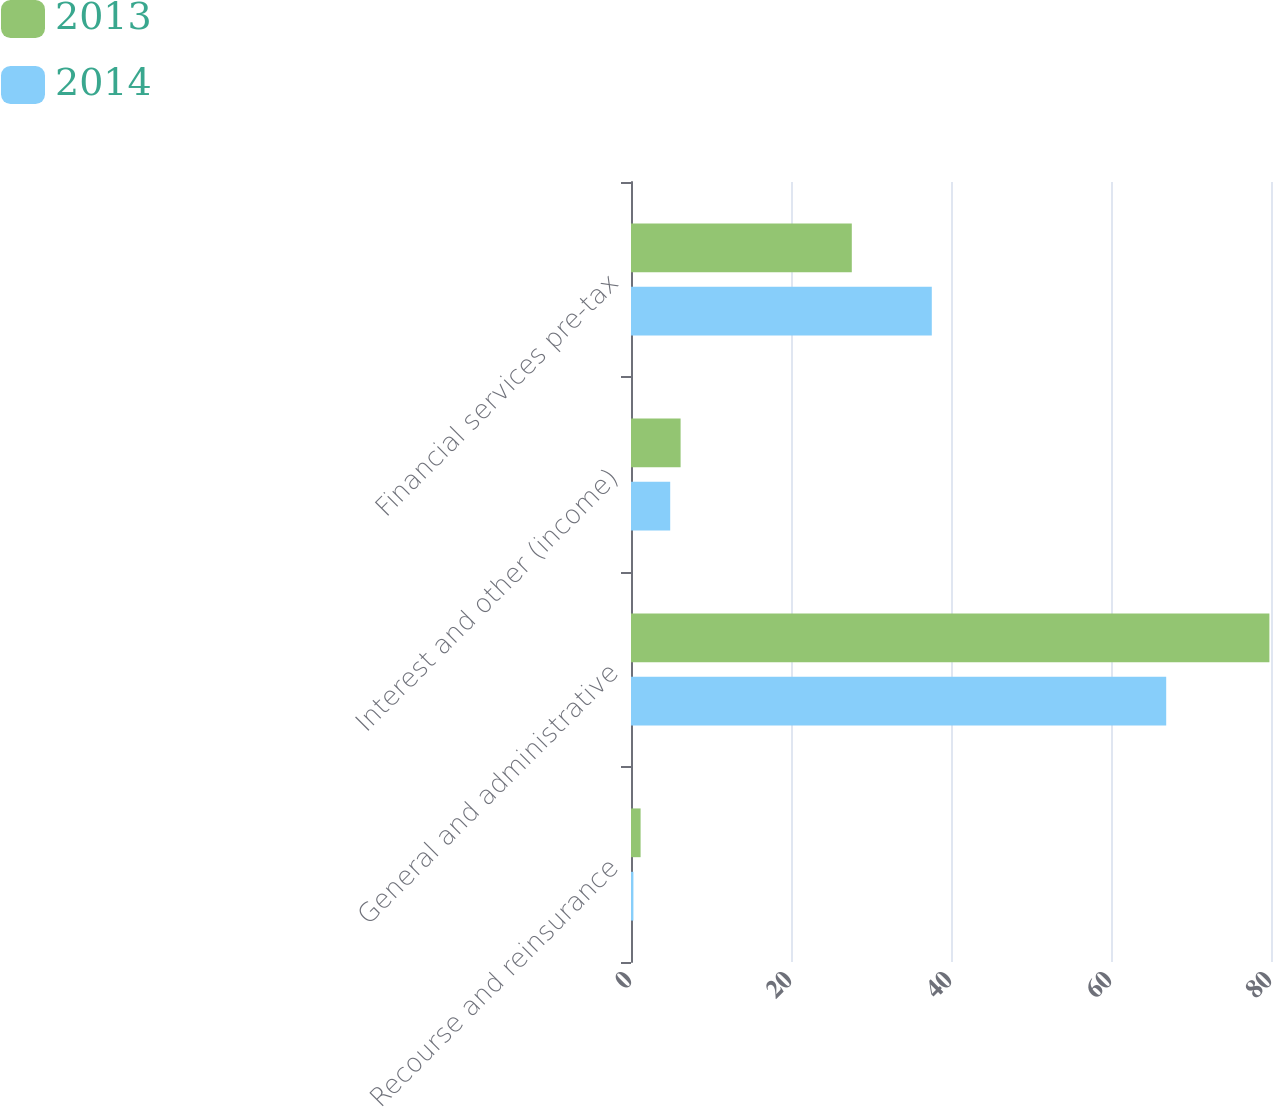<chart> <loc_0><loc_0><loc_500><loc_500><stacked_bar_chart><ecel><fcel>Recourse and reinsurance<fcel>General and administrative<fcel>Interest and other (income)<fcel>Financial services pre-tax<nl><fcel>2013<fcel>1.2<fcel>79.8<fcel>6.2<fcel>27.6<nl><fcel>2014<fcel>0.3<fcel>66.9<fcel>4.9<fcel>37.6<nl></chart> 